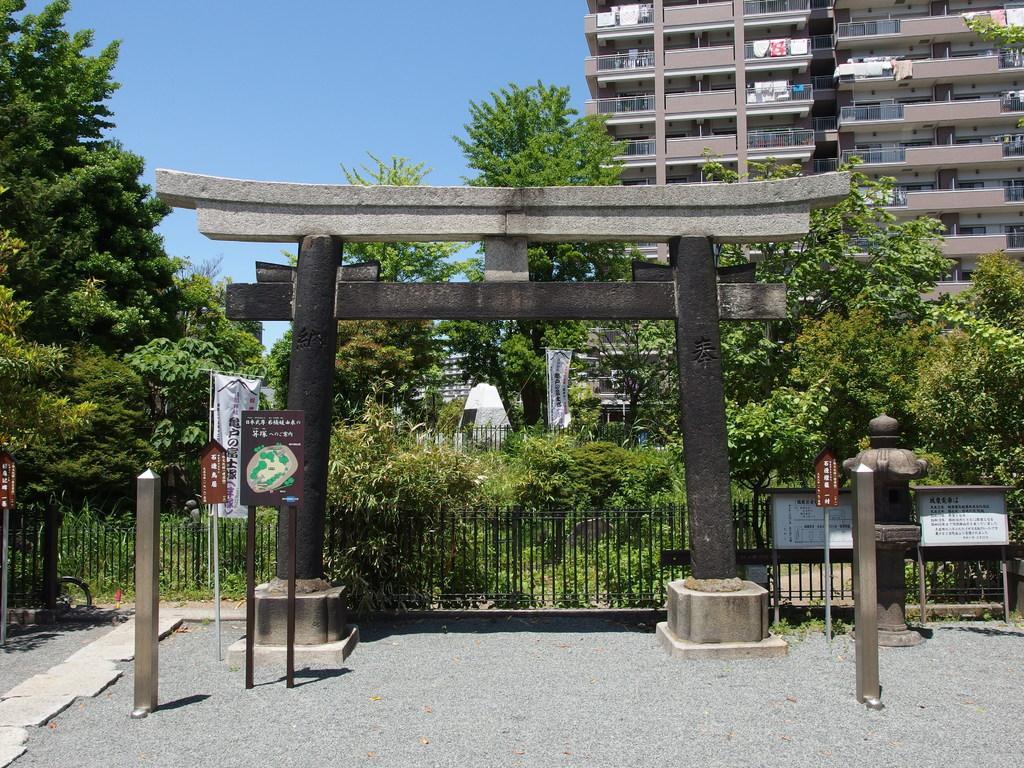Please provide a concise description of this image. In the center of the image there is an arch. In the background we can see many trees and also buildings. Image also consists of name boards and also fence. At the bottom there is path and at the top there is sky. 